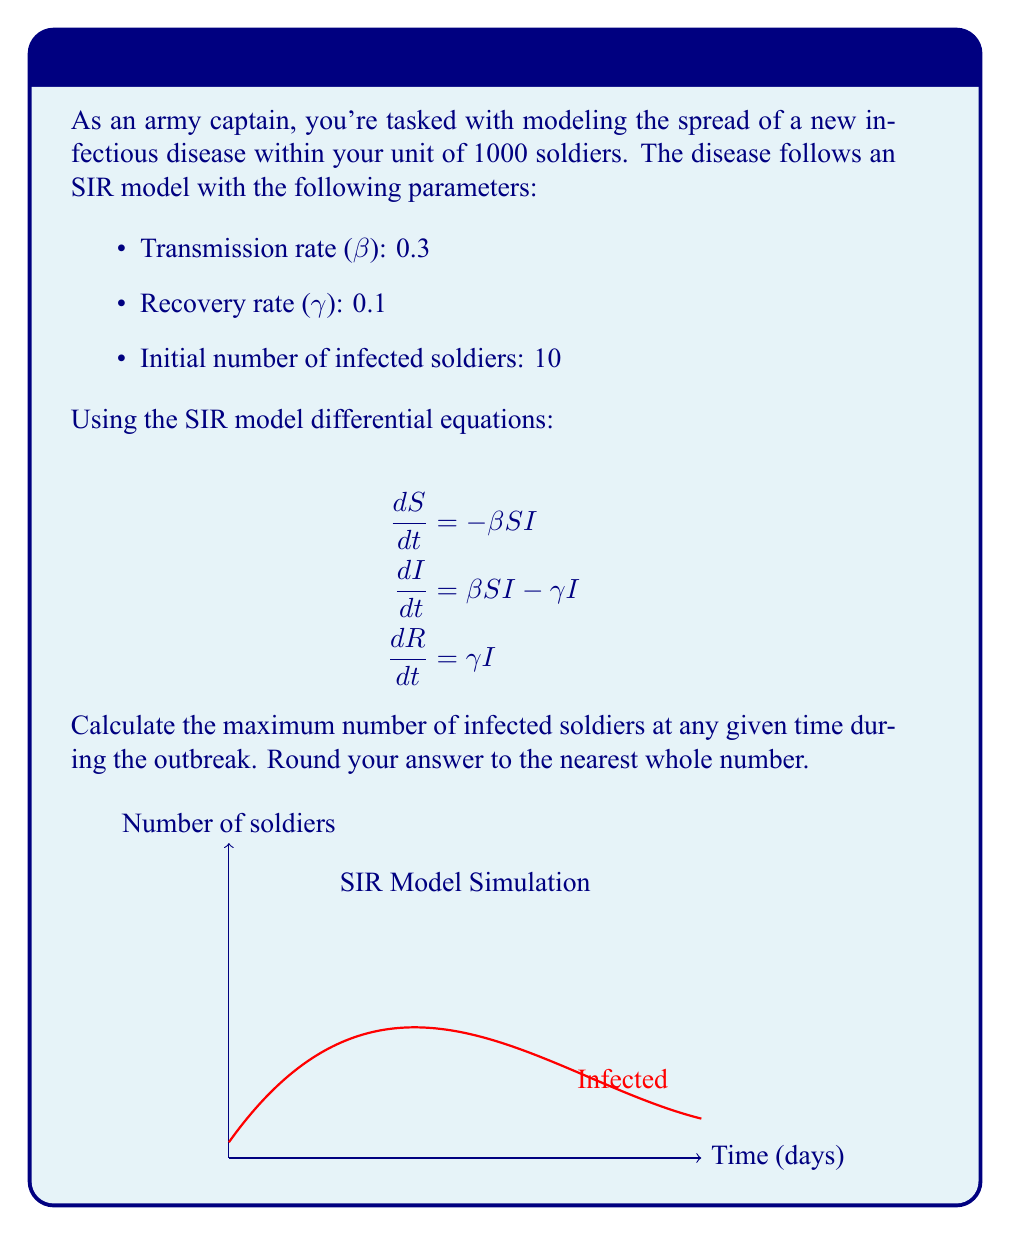Show me your answer to this math problem. To find the maximum number of infected soldiers, we need to analyze the SIR model equations:

1. First, we calculate the basic reproduction number R₀:
   $$R_0 = \frac{\beta}{\gamma} = \frac{0.3}{0.1} = 3$$

2. Since R₀ > 1, an epidemic will occur.

3. The maximum number of infected occurs when dI/dt = 0:
   $$\beta SI - \gamma I = 0$$
   $$\beta S = \gamma$$
   $$S = \frac{\gamma}{\beta} = \frac{0.1}{0.3} = \frac{1}{3}N$$

4. At this point, S = N/3 = 1000/3 ≈ 333 susceptible soldiers.

5. Using the conservation of population:
   $$N = S + I + R$$
   $$1000 = 333 + I + R$$

6. We can find I + R:
   $$I + R = 1000 - 333 = 667$$

7. The maximum number of infected (I) occurs when R is at its minimum. Initially, R = 0, so the maximum I is:
   $$I_{max} = 667$$

8. Rounding to the nearest whole number:
   $$I_{max} ≈ 667$$

Therefore, the maximum number of infected soldiers at any given time during the outbreak is approximately 667.
Answer: 667 